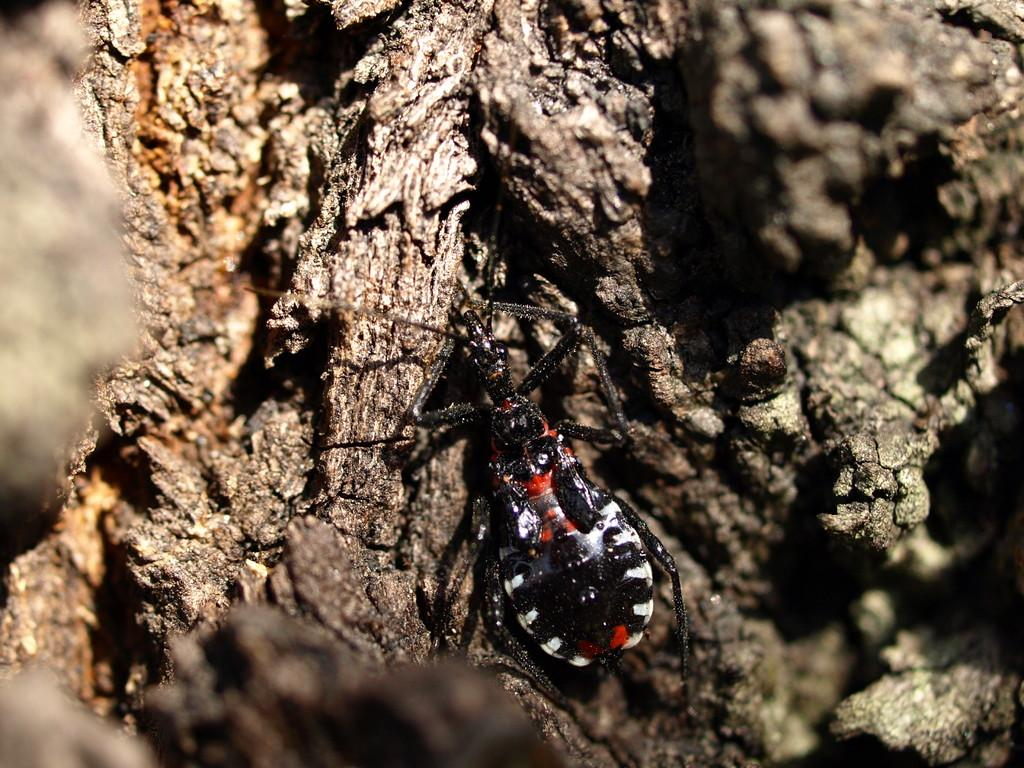What is present in the image? There is an insect in the image. Where is the insect located? The insect is on the trunk of a tree. How does the insect wave to the camera in the image? The insect does not wave to the camera in the image; it is simply present on the trunk of the tree. 